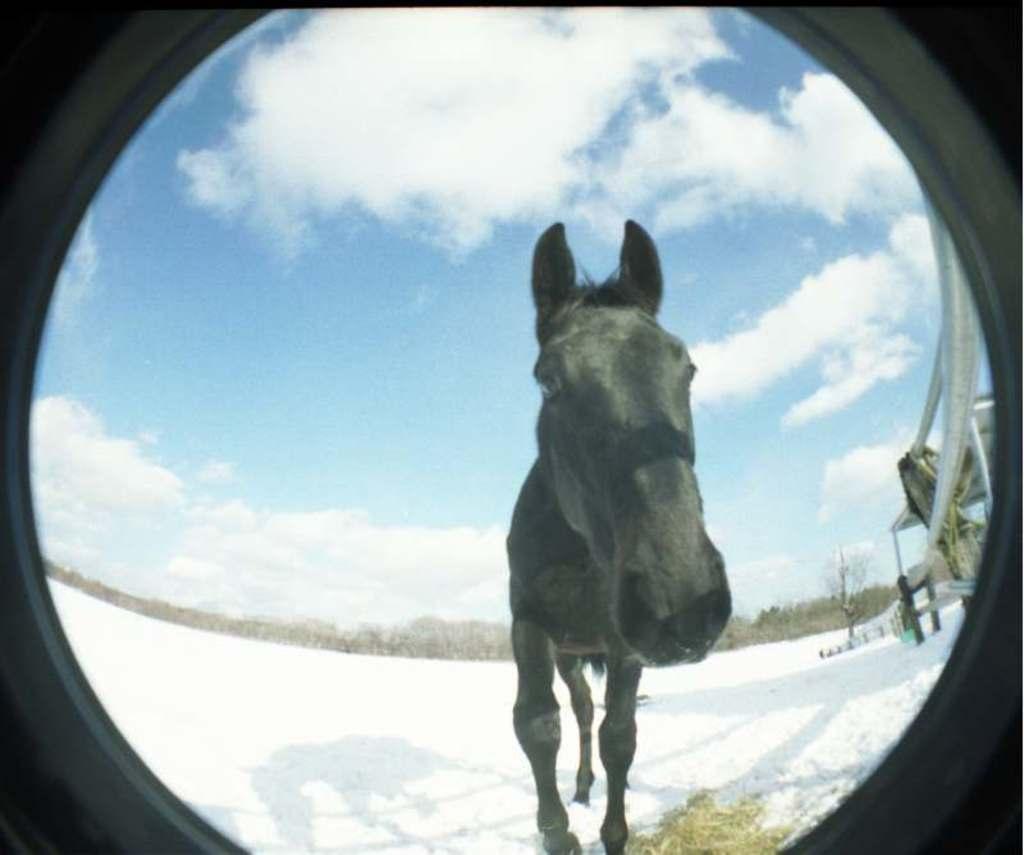Could you give a brief overview of what you see in this image? In front of the image through a hole we can see a horse on the snow surface, behind the horse there are metal rods, some objects and trees. At the top of the image there are clouds in the sky. 